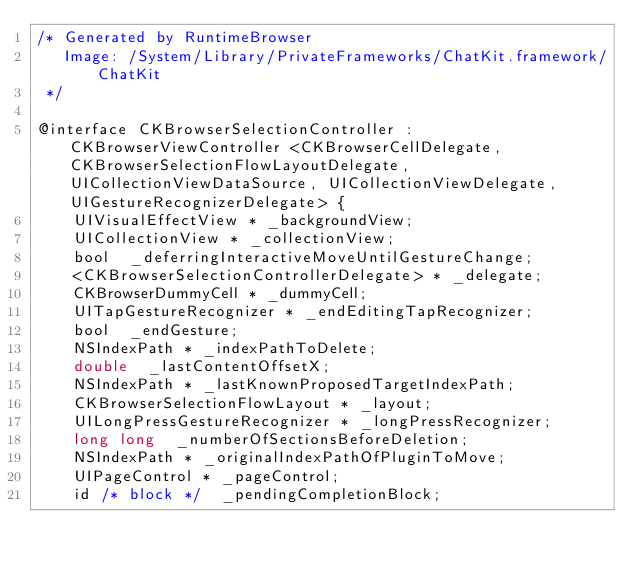Convert code to text. <code><loc_0><loc_0><loc_500><loc_500><_C_>/* Generated by RuntimeBrowser
   Image: /System/Library/PrivateFrameworks/ChatKit.framework/ChatKit
 */

@interface CKBrowserSelectionController : CKBrowserViewController <CKBrowserCellDelegate, CKBrowserSelectionFlowLayoutDelegate, UICollectionViewDataSource, UICollectionViewDelegate, UIGestureRecognizerDelegate> {
    UIVisualEffectView * _backgroundView;
    UICollectionView * _collectionView;
    bool  _deferringInteractiveMoveUntilGestureChange;
    <CKBrowserSelectionControllerDelegate> * _delegate;
    CKBrowserDummyCell * _dummyCell;
    UITapGestureRecognizer * _endEditingTapRecognizer;
    bool  _endGesture;
    NSIndexPath * _indexPathToDelete;
    double  _lastContentOffsetX;
    NSIndexPath * _lastKnownProposedTargetIndexPath;
    CKBrowserSelectionFlowLayout * _layout;
    UILongPressGestureRecognizer * _longPressRecognizer;
    long long  _numberOfSectionsBeforeDeletion;
    NSIndexPath * _originalIndexPathOfPluginToMove;
    UIPageControl * _pageControl;
    id /* block */  _pendingCompletionBlock;</code> 